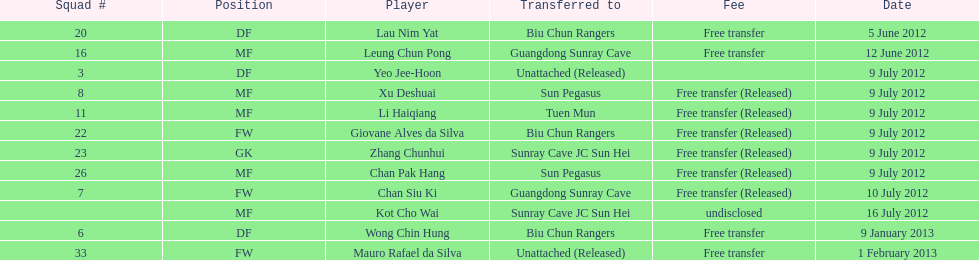Which player is named first in the list? Lau Nim Yat. 